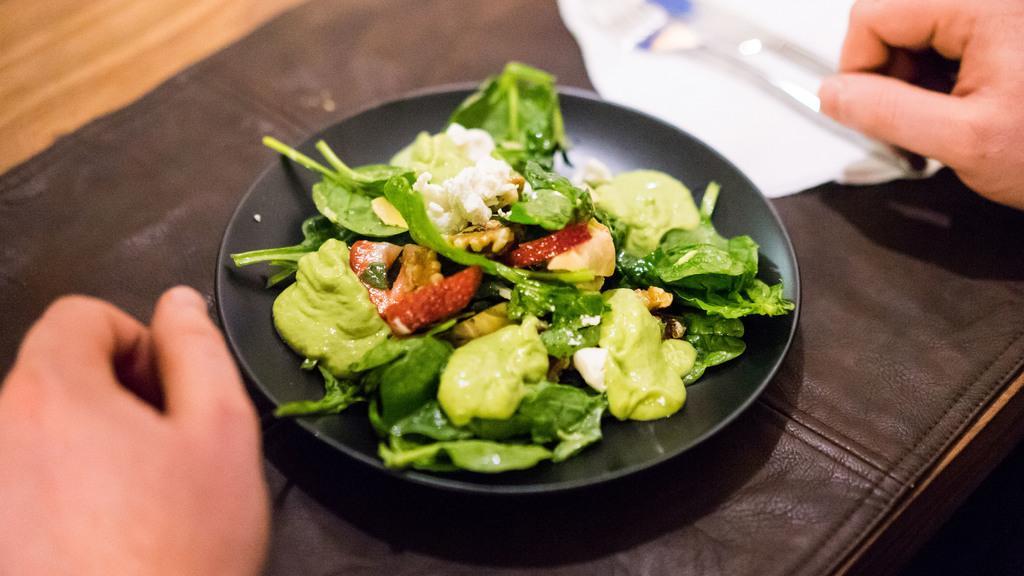How would you summarize this image in a sentence or two? In this image I can see a brown colored table and on the table I can see the brown colored sheet and on it I can see a black colored plate. In the plate I can see a salad which is green, red and white in color. I can see persons hands and a tissue with few spoons on it. 